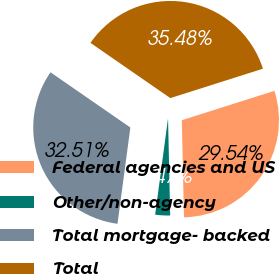<chart> <loc_0><loc_0><loc_500><loc_500><pie_chart><fcel>Federal agencies and US<fcel>Other/non-agency<fcel>Total mortgage- backed<fcel>Total<nl><fcel>29.54%<fcel>2.47%<fcel>32.51%<fcel>35.48%<nl></chart> 